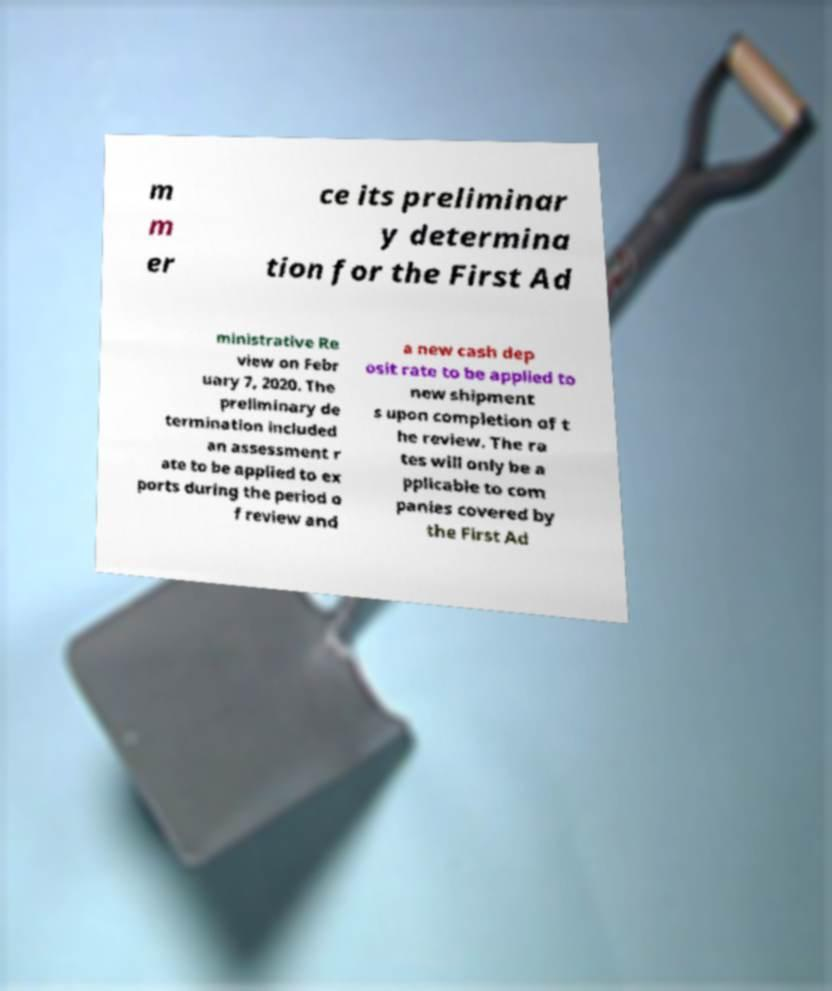I need the written content from this picture converted into text. Can you do that? m m er ce its preliminar y determina tion for the First Ad ministrative Re view on Febr uary 7, 2020. The preliminary de termination included an assessment r ate to be applied to ex ports during the period o f review and a new cash dep osit rate to be applied to new shipment s upon completion of t he review. The ra tes will only be a pplicable to com panies covered by the First Ad 